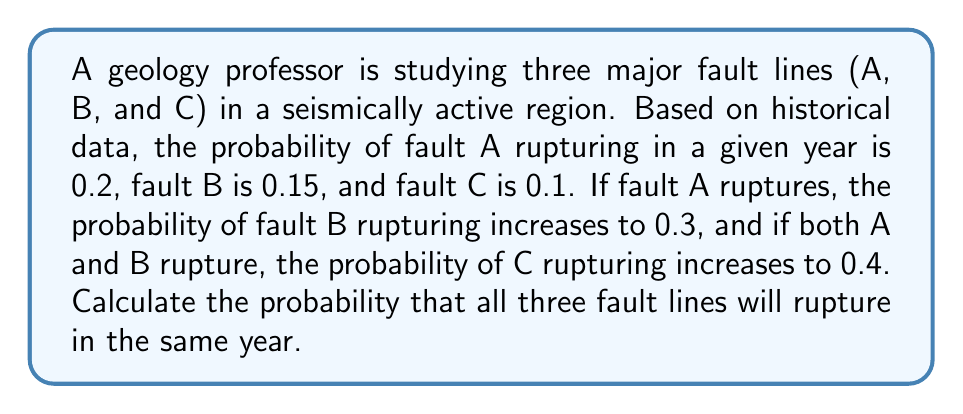Could you help me with this problem? Let's approach this step-by-step using conditional probability:

1) Define events:
   A: Fault A ruptures
   B: Fault B ruptures
   C: Fault C ruptures

2) Given probabilities:
   P(A) = 0.2
   P(B) = 0.15
   P(C) = 0.1
   P(B|A) = 0.3 (probability of B given A has occurred)
   P(C|A∩B) = 0.4 (probability of C given both A and B have occurred)

3) We need to calculate P(A∩B∩C), which can be expressed as:
   P(A∩B∩C) = P(A) × P(B|A) × P(C|A∩B)

4) Substituting the values:
   P(A∩B∩C) = 0.2 × 0.3 × 0.4

5) Calculate:
   P(A∩B∩C) = 0.2 × 0.3 × 0.4 = 0.024

Therefore, the probability that all three fault lines will rupture in the same year is 0.024 or 2.4%.
Answer: 0.024 